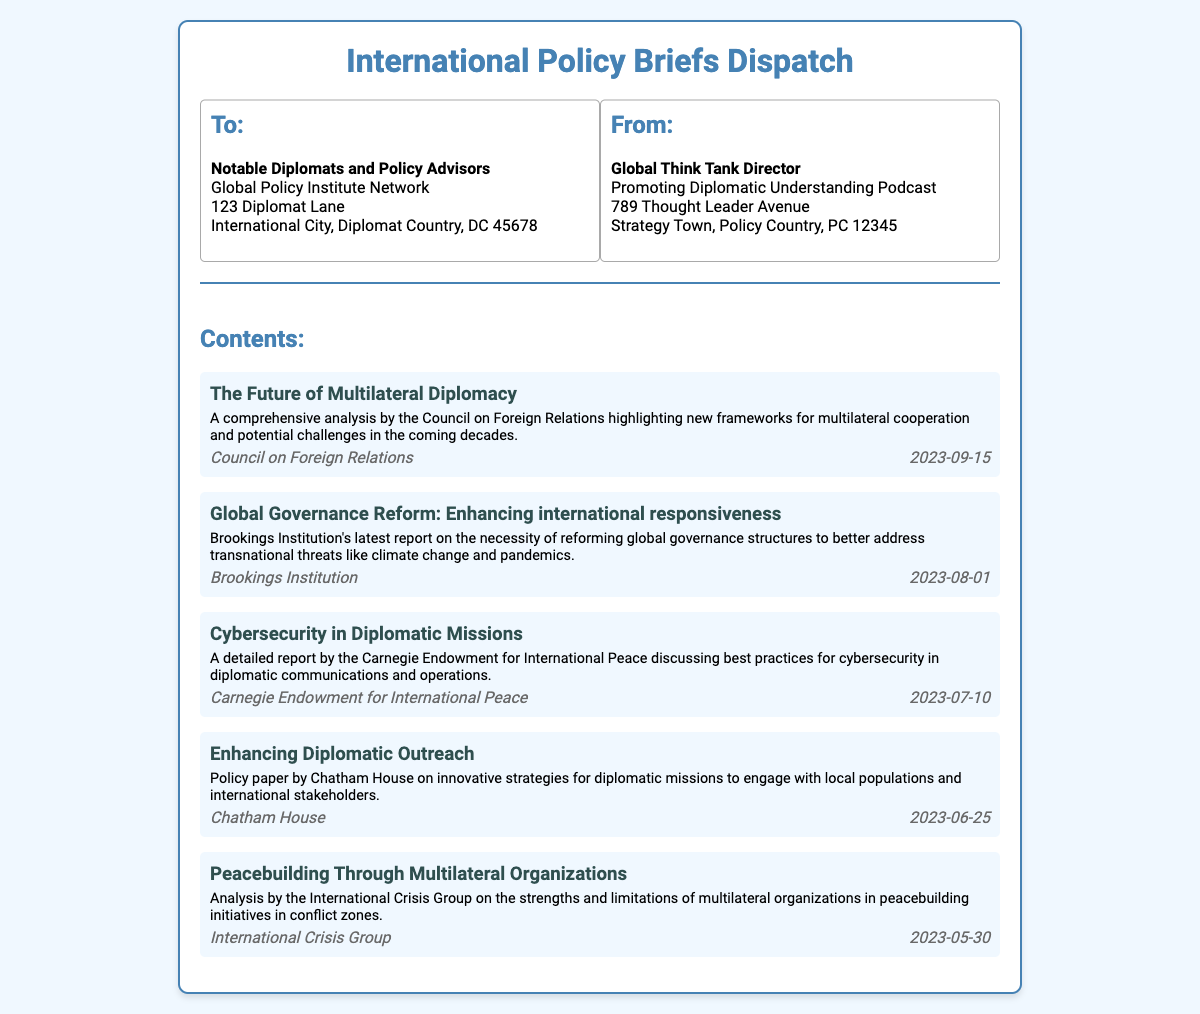What is the title of the document? The title is at the top of the shipping label, stating the purpose of the document.
Answer: International Policy Briefs Dispatch Who is the recipient of the dispatch? The recipient information can be found in the address section labeled "To:".
Answer: Notable Diplomats and Policy Advisors What organization authored the first content item? The author information is provided with each content item listed under "Contents:".
Answer: Council on Foreign Relations On what date was the report "Global Governance Reform: Enhancing international responsiveness" published? The publication date is mentioned alongside the author's name for each report.
Answer: 2023-08-01 What is the theme of the report titled "Cybersecurity in Diplomatic Missions"? The theme is summarized in the brief description provided for each content item.
Answer: Best practices for cybersecurity Which institution contributed to the analysis on peacebuilding? The specific institution responsible for the analysis is specified under the content item details.
Answer: International Crisis Group How many content items are listed in the dispatch? The number can be counted by reviewing the individual content item sections under "Contents:".
Answer: Five 